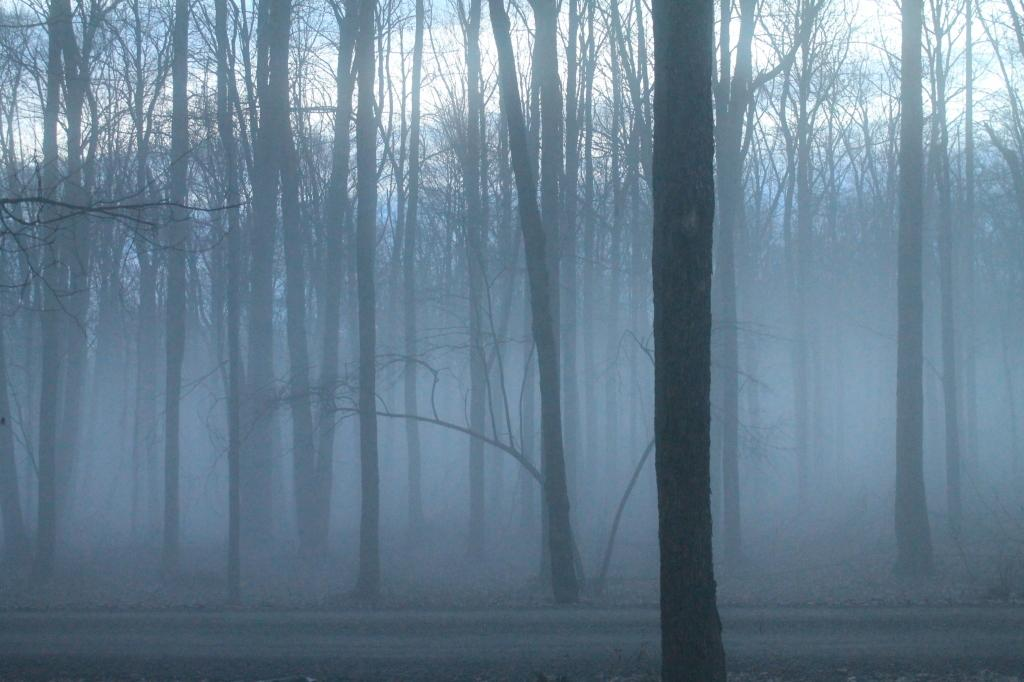What is one of the main features of the image? There is a road in the image. What type of natural elements can be seen in the image? There are trees in the image. What atmospheric condition is visible in the image? There is fog visible in the image. What part of the natural environment is visible in the image? The sky is visible in the background of the image. What type of lumber is being used to construct the hall in the image? There is no hall or lumber present in the image. How does the light from the street lamps affect the visibility of the road in the image? There is no mention of street lamps or lighting conditions in the image, so it cannot be determined how the light affects the visibility of the road. 